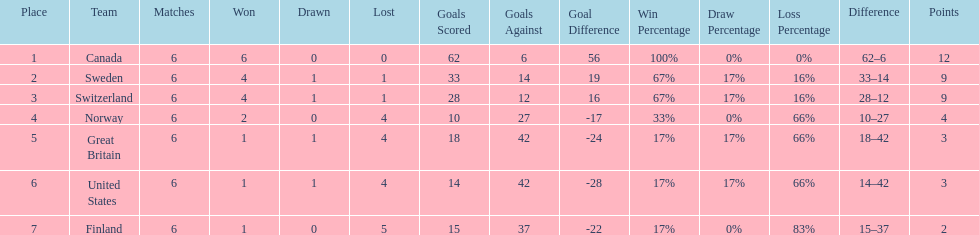Which country conceded the least goals? Finland. 